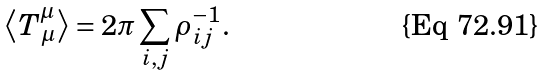Convert formula to latex. <formula><loc_0><loc_0><loc_500><loc_500>\left \langle T _ { \, \mu } ^ { \mu } \right \rangle = 2 \pi \sum _ { i , j } \rho _ { i j } ^ { - 1 } .</formula> 